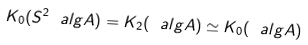<formula> <loc_0><loc_0><loc_500><loc_500>K _ { 0 } ( S ^ { 2 } \ a l g A ) = K _ { 2 } ( \ a l g A ) \simeq K _ { 0 } ( \ a l g A )</formula> 